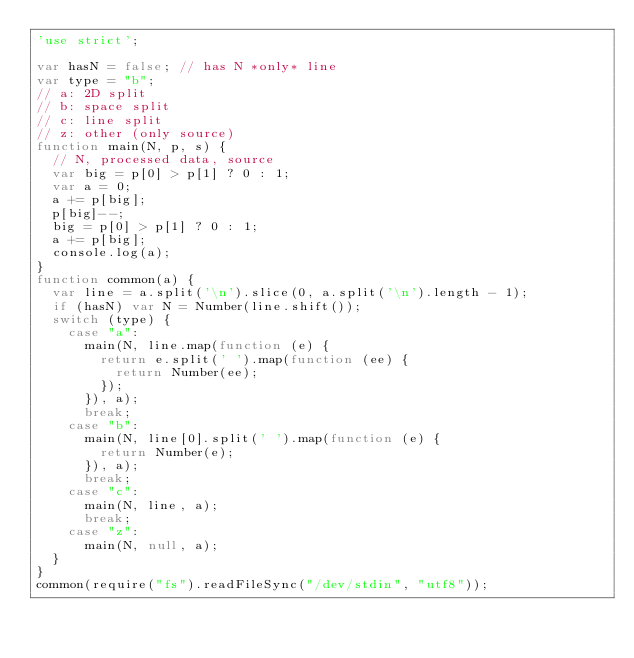<code> <loc_0><loc_0><loc_500><loc_500><_JavaScript_>'use strict';

var hasN = false; // has N *only* line
var type = "b";
// a: 2D split
// b: space split
// c: line split
// z: other (only source)
function main(N, p, s) {
  // N, processed data, source
  var big = p[0] > p[1] ? 0 : 1;
  var a = 0;
  a += p[big];
  p[big]--;
  big = p[0] > p[1] ? 0 : 1;
  a += p[big];
  console.log(a);
}
function common(a) {
  var line = a.split('\n').slice(0, a.split('\n').length - 1);
  if (hasN) var N = Number(line.shift());
  switch (type) {
    case "a":
      main(N, line.map(function (e) {
        return e.split(' ').map(function (ee) {
          return Number(ee);
        });
      }), a);
      break;
    case "b":
      main(N, line[0].split(' ').map(function (e) {
        return Number(e);
      }), a);
      break;
    case "c":
      main(N, line, a);
      break;
    case "z":
      main(N, null, a);
  }
}
common(require("fs").readFileSync("/dev/stdin", "utf8"));
</code> 